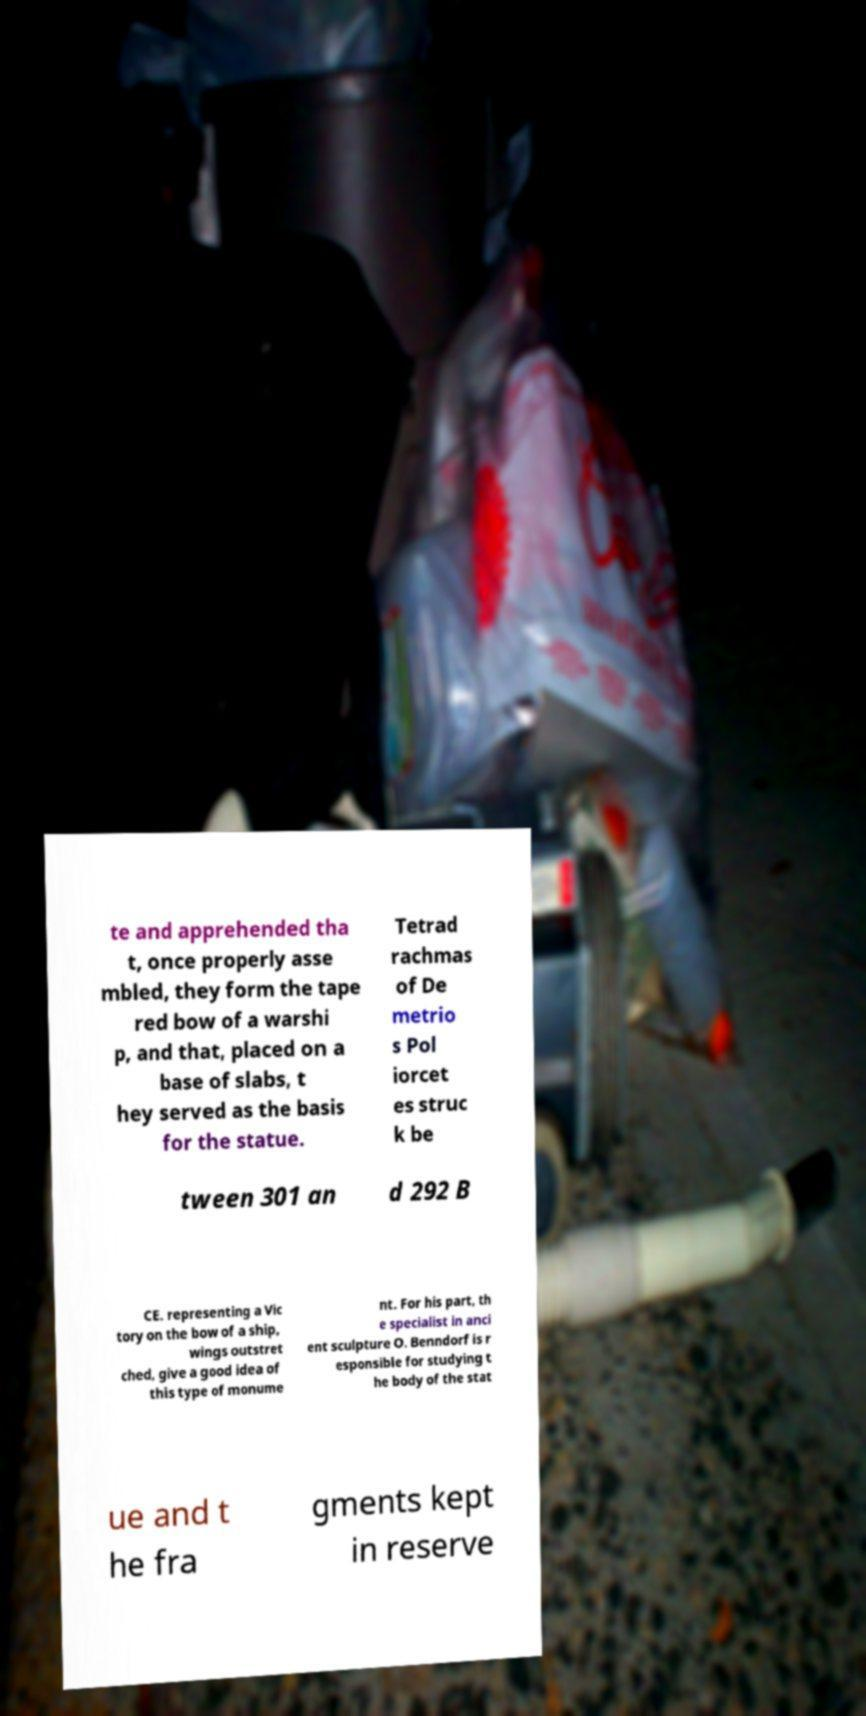Could you assist in decoding the text presented in this image and type it out clearly? te and apprehended tha t, once properly asse mbled, they form the tape red bow of a warshi p, and that, placed on a base of slabs, t hey served as the basis for the statue. Tetrad rachmas of De metrio s Pol iorcet es struc k be tween 301 an d 292 B CE. representing a Vic tory on the bow of a ship, wings outstret ched, give a good idea of this type of monume nt. For his part, th e specialist in anci ent sculpture O. Benndorf is r esponsible for studying t he body of the stat ue and t he fra gments kept in reserve 